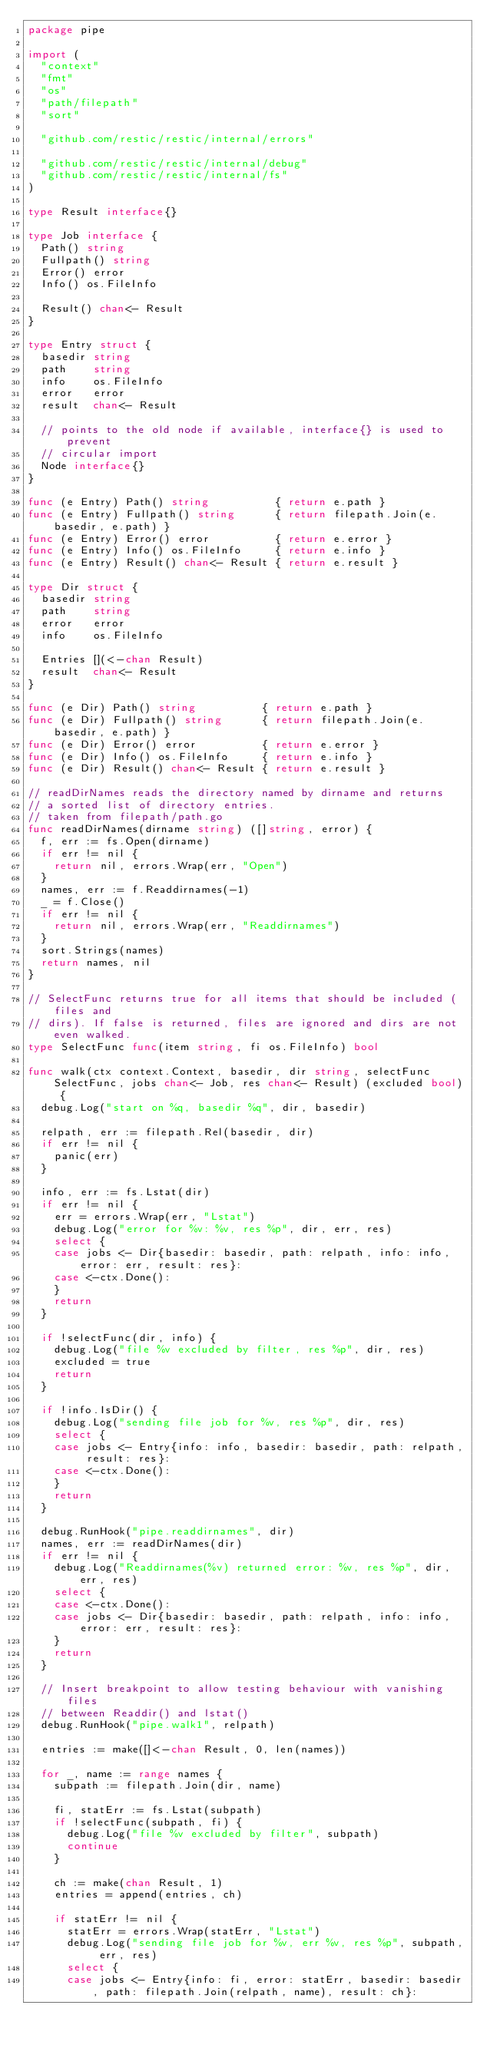<code> <loc_0><loc_0><loc_500><loc_500><_Go_>package pipe

import (
	"context"
	"fmt"
	"os"
	"path/filepath"
	"sort"

	"github.com/restic/restic/internal/errors"

	"github.com/restic/restic/internal/debug"
	"github.com/restic/restic/internal/fs"
)

type Result interface{}

type Job interface {
	Path() string
	Fullpath() string
	Error() error
	Info() os.FileInfo

	Result() chan<- Result
}

type Entry struct {
	basedir string
	path    string
	info    os.FileInfo
	error   error
	result  chan<- Result

	// points to the old node if available, interface{} is used to prevent
	// circular import
	Node interface{}
}

func (e Entry) Path() string          { return e.path }
func (e Entry) Fullpath() string      { return filepath.Join(e.basedir, e.path) }
func (e Entry) Error() error          { return e.error }
func (e Entry) Info() os.FileInfo     { return e.info }
func (e Entry) Result() chan<- Result { return e.result }

type Dir struct {
	basedir string
	path    string
	error   error
	info    os.FileInfo

	Entries [](<-chan Result)
	result  chan<- Result
}

func (e Dir) Path() string          { return e.path }
func (e Dir) Fullpath() string      { return filepath.Join(e.basedir, e.path) }
func (e Dir) Error() error          { return e.error }
func (e Dir) Info() os.FileInfo     { return e.info }
func (e Dir) Result() chan<- Result { return e.result }

// readDirNames reads the directory named by dirname and returns
// a sorted list of directory entries.
// taken from filepath/path.go
func readDirNames(dirname string) ([]string, error) {
	f, err := fs.Open(dirname)
	if err != nil {
		return nil, errors.Wrap(err, "Open")
	}
	names, err := f.Readdirnames(-1)
	_ = f.Close()
	if err != nil {
		return nil, errors.Wrap(err, "Readdirnames")
	}
	sort.Strings(names)
	return names, nil
}

// SelectFunc returns true for all items that should be included (files and
// dirs). If false is returned, files are ignored and dirs are not even walked.
type SelectFunc func(item string, fi os.FileInfo) bool

func walk(ctx context.Context, basedir, dir string, selectFunc SelectFunc, jobs chan<- Job, res chan<- Result) (excluded bool) {
	debug.Log("start on %q, basedir %q", dir, basedir)

	relpath, err := filepath.Rel(basedir, dir)
	if err != nil {
		panic(err)
	}

	info, err := fs.Lstat(dir)
	if err != nil {
		err = errors.Wrap(err, "Lstat")
		debug.Log("error for %v: %v, res %p", dir, err, res)
		select {
		case jobs <- Dir{basedir: basedir, path: relpath, info: info, error: err, result: res}:
		case <-ctx.Done():
		}
		return
	}

	if !selectFunc(dir, info) {
		debug.Log("file %v excluded by filter, res %p", dir, res)
		excluded = true
		return
	}

	if !info.IsDir() {
		debug.Log("sending file job for %v, res %p", dir, res)
		select {
		case jobs <- Entry{info: info, basedir: basedir, path: relpath, result: res}:
		case <-ctx.Done():
		}
		return
	}

	debug.RunHook("pipe.readdirnames", dir)
	names, err := readDirNames(dir)
	if err != nil {
		debug.Log("Readdirnames(%v) returned error: %v, res %p", dir, err, res)
		select {
		case <-ctx.Done():
		case jobs <- Dir{basedir: basedir, path: relpath, info: info, error: err, result: res}:
		}
		return
	}

	// Insert breakpoint to allow testing behaviour with vanishing files
	// between Readdir() and lstat()
	debug.RunHook("pipe.walk1", relpath)

	entries := make([]<-chan Result, 0, len(names))

	for _, name := range names {
		subpath := filepath.Join(dir, name)

		fi, statErr := fs.Lstat(subpath)
		if !selectFunc(subpath, fi) {
			debug.Log("file %v excluded by filter", subpath)
			continue
		}

		ch := make(chan Result, 1)
		entries = append(entries, ch)

		if statErr != nil {
			statErr = errors.Wrap(statErr, "Lstat")
			debug.Log("sending file job for %v, err %v, res %p", subpath, err, res)
			select {
			case jobs <- Entry{info: fi, error: statErr, basedir: basedir, path: filepath.Join(relpath, name), result: ch}:</code> 